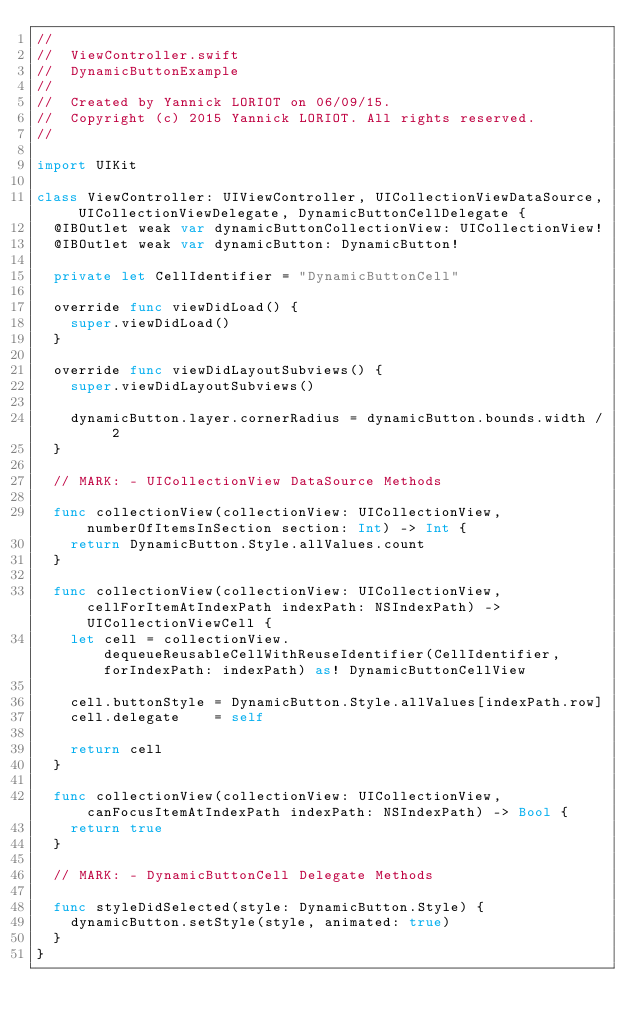Convert code to text. <code><loc_0><loc_0><loc_500><loc_500><_Swift_>//
//  ViewController.swift
//  DynamicButtonExample
//
//  Created by Yannick LORIOT on 06/09/15.
//  Copyright (c) 2015 Yannick LORIOT. All rights reserved.
//

import UIKit

class ViewController: UIViewController, UICollectionViewDataSource, UICollectionViewDelegate, DynamicButtonCellDelegate {
  @IBOutlet weak var dynamicButtonCollectionView: UICollectionView!
  @IBOutlet weak var dynamicButton: DynamicButton!

  private let CellIdentifier = "DynamicButtonCell"

  override func viewDidLoad() {
    super.viewDidLoad()
  }

  override func viewDidLayoutSubviews() {
    super.viewDidLayoutSubviews()

    dynamicButton.layer.cornerRadius = dynamicButton.bounds.width / 2
  }
  
  // MARK: - UICollectionView DataSource Methods

  func collectionView(collectionView: UICollectionView, numberOfItemsInSection section: Int) -> Int {
    return DynamicButton.Style.allValues.count
  }

  func collectionView(collectionView: UICollectionView, cellForItemAtIndexPath indexPath: NSIndexPath) -> UICollectionViewCell {
    let cell = collectionView.dequeueReusableCellWithReuseIdentifier(CellIdentifier, forIndexPath: indexPath) as! DynamicButtonCellView

    cell.buttonStyle = DynamicButton.Style.allValues[indexPath.row]
    cell.delegate    = self

    return cell
  }

  func collectionView(collectionView: UICollectionView, canFocusItemAtIndexPath indexPath: NSIndexPath) -> Bool {
    return true
  }

  // MARK: - DynamicButtonCell Delegate Methods

  func styleDidSelected(style: DynamicButton.Style) {
    dynamicButton.setStyle(style, animated: true)
  }
}

</code> 